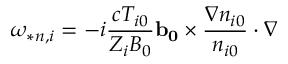<formula> <loc_0><loc_0><loc_500><loc_500>\omega _ { * n , i } = - i \frac { c T _ { i 0 } } { Z _ { i } B _ { 0 } } b _ { 0 } \times \frac { \nabla n _ { i 0 } } { n _ { i 0 } } \cdot \nabla</formula> 